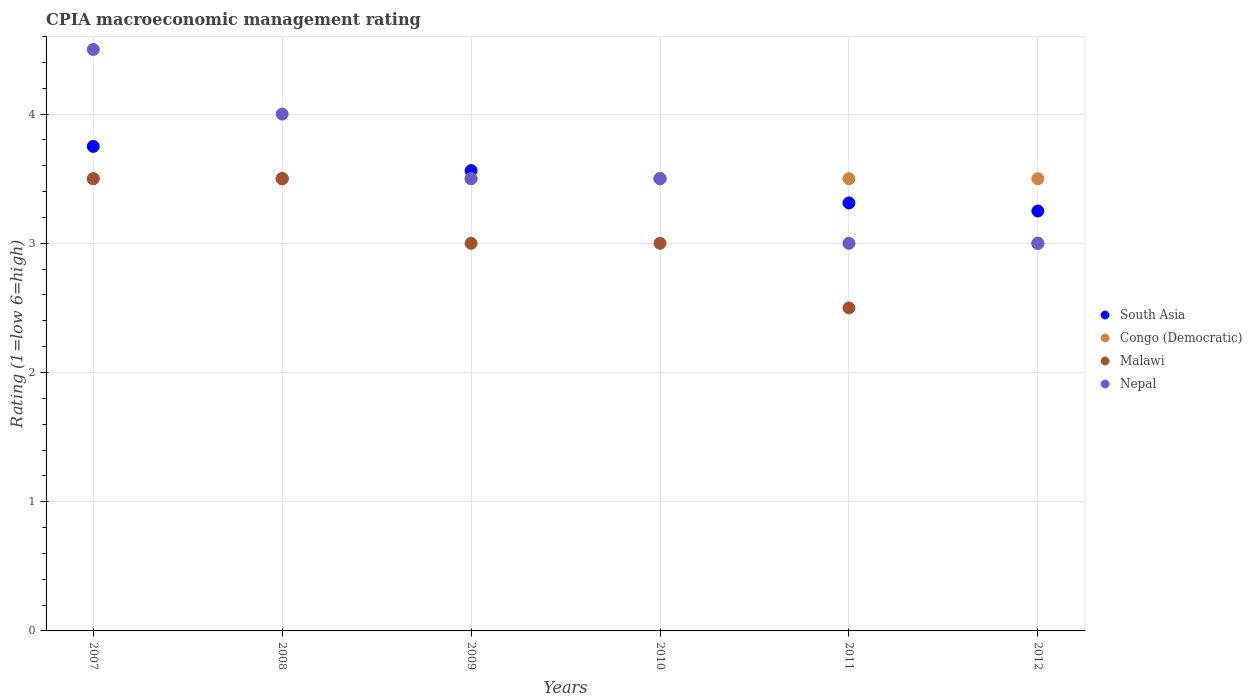How many different coloured dotlines are there?
Provide a succinct answer. 4. What is the CPIA rating in South Asia in 2009?
Your response must be concise. 3.56. Across all years, what is the maximum CPIA rating in South Asia?
Ensure brevity in your answer.  3.75. Across all years, what is the minimum CPIA rating in South Asia?
Make the answer very short. 3.25. In which year was the CPIA rating in Malawi minimum?
Your answer should be very brief. 2011. What is the difference between the CPIA rating in South Asia in 2010 and that in 2012?
Give a very brief answer. 0.25. What is the difference between the CPIA rating in Malawi in 2011 and the CPIA rating in South Asia in 2010?
Keep it short and to the point. -1. What is the ratio of the CPIA rating in South Asia in 2008 to that in 2012?
Offer a very short reply. 1.08. Is the CPIA rating in South Asia in 2010 less than that in 2012?
Provide a short and direct response. No. Is the difference between the CPIA rating in Malawi in 2009 and 2010 greater than the difference between the CPIA rating in South Asia in 2009 and 2010?
Give a very brief answer. No. What is the difference between the highest and the second highest CPIA rating in Nepal?
Offer a very short reply. 0.5. What is the difference between the highest and the lowest CPIA rating in Nepal?
Offer a very short reply. 1.5. Is the sum of the CPIA rating in Congo (Democratic) in 2008 and 2012 greater than the maximum CPIA rating in Nepal across all years?
Your response must be concise. Yes. Is it the case that in every year, the sum of the CPIA rating in Nepal and CPIA rating in South Asia  is greater than the sum of CPIA rating in Congo (Democratic) and CPIA rating in Malawi?
Ensure brevity in your answer.  No. Is it the case that in every year, the sum of the CPIA rating in Malawi and CPIA rating in Nepal  is greater than the CPIA rating in South Asia?
Your answer should be very brief. Yes. Does the CPIA rating in South Asia monotonically increase over the years?
Offer a very short reply. No. Is the CPIA rating in Nepal strictly greater than the CPIA rating in Malawi over the years?
Your answer should be very brief. No. Is the CPIA rating in Congo (Democratic) strictly less than the CPIA rating in Nepal over the years?
Provide a succinct answer. No. What is the difference between two consecutive major ticks on the Y-axis?
Give a very brief answer. 1. How many legend labels are there?
Provide a succinct answer. 4. How are the legend labels stacked?
Your answer should be compact. Vertical. What is the title of the graph?
Offer a very short reply. CPIA macroeconomic management rating. What is the Rating (1=low 6=high) in South Asia in 2007?
Provide a succinct answer. 3.75. What is the Rating (1=low 6=high) in Malawi in 2007?
Ensure brevity in your answer.  3.5. What is the Rating (1=low 6=high) in Congo (Democratic) in 2008?
Your answer should be very brief. 3.5. What is the Rating (1=low 6=high) in Nepal in 2008?
Give a very brief answer. 4. What is the Rating (1=low 6=high) of South Asia in 2009?
Ensure brevity in your answer.  3.56. What is the Rating (1=low 6=high) of Congo (Democratic) in 2009?
Provide a short and direct response. 3.5. What is the Rating (1=low 6=high) in Nepal in 2009?
Make the answer very short. 3.5. What is the Rating (1=low 6=high) in South Asia in 2010?
Your answer should be very brief. 3.5. What is the Rating (1=low 6=high) in Congo (Democratic) in 2010?
Your response must be concise. 3.5. What is the Rating (1=low 6=high) of South Asia in 2011?
Give a very brief answer. 3.31. What is the Rating (1=low 6=high) in Nepal in 2011?
Your answer should be compact. 3. What is the Rating (1=low 6=high) in South Asia in 2012?
Offer a very short reply. 3.25. What is the Rating (1=low 6=high) in Malawi in 2012?
Your answer should be compact. 3. Across all years, what is the maximum Rating (1=low 6=high) of South Asia?
Your answer should be compact. 3.75. Across all years, what is the maximum Rating (1=low 6=high) of Nepal?
Make the answer very short. 4.5. Across all years, what is the minimum Rating (1=low 6=high) of Congo (Democratic)?
Ensure brevity in your answer.  3.5. Across all years, what is the minimum Rating (1=low 6=high) of Nepal?
Provide a short and direct response. 3. What is the total Rating (1=low 6=high) of South Asia in the graph?
Provide a succinct answer. 20.88. What is the total Rating (1=low 6=high) of Congo (Democratic) in the graph?
Offer a terse response. 21. What is the difference between the Rating (1=low 6=high) in Congo (Democratic) in 2007 and that in 2008?
Your answer should be very brief. 0. What is the difference between the Rating (1=low 6=high) in Nepal in 2007 and that in 2008?
Your answer should be very brief. 0.5. What is the difference between the Rating (1=low 6=high) in South Asia in 2007 and that in 2009?
Offer a terse response. 0.19. What is the difference between the Rating (1=low 6=high) of Congo (Democratic) in 2007 and that in 2009?
Keep it short and to the point. 0. What is the difference between the Rating (1=low 6=high) of South Asia in 2007 and that in 2010?
Your response must be concise. 0.25. What is the difference between the Rating (1=low 6=high) of Malawi in 2007 and that in 2010?
Your response must be concise. 0.5. What is the difference between the Rating (1=low 6=high) of Nepal in 2007 and that in 2010?
Provide a succinct answer. 1. What is the difference between the Rating (1=low 6=high) of South Asia in 2007 and that in 2011?
Give a very brief answer. 0.44. What is the difference between the Rating (1=low 6=high) of Malawi in 2007 and that in 2012?
Provide a succinct answer. 0.5. What is the difference between the Rating (1=low 6=high) of Nepal in 2007 and that in 2012?
Provide a short and direct response. 1.5. What is the difference between the Rating (1=low 6=high) in South Asia in 2008 and that in 2009?
Offer a very short reply. -0.06. What is the difference between the Rating (1=low 6=high) in Congo (Democratic) in 2008 and that in 2009?
Make the answer very short. 0. What is the difference between the Rating (1=low 6=high) of Congo (Democratic) in 2008 and that in 2010?
Offer a very short reply. 0. What is the difference between the Rating (1=low 6=high) in South Asia in 2008 and that in 2011?
Ensure brevity in your answer.  0.19. What is the difference between the Rating (1=low 6=high) of Congo (Democratic) in 2008 and that in 2011?
Make the answer very short. 0. What is the difference between the Rating (1=low 6=high) of Malawi in 2008 and that in 2011?
Your response must be concise. 1. What is the difference between the Rating (1=low 6=high) of Congo (Democratic) in 2008 and that in 2012?
Give a very brief answer. 0. What is the difference between the Rating (1=low 6=high) in South Asia in 2009 and that in 2010?
Your answer should be compact. 0.06. What is the difference between the Rating (1=low 6=high) of Congo (Democratic) in 2009 and that in 2010?
Provide a succinct answer. 0. What is the difference between the Rating (1=low 6=high) in Malawi in 2009 and that in 2010?
Your response must be concise. 0. What is the difference between the Rating (1=low 6=high) of Congo (Democratic) in 2009 and that in 2011?
Keep it short and to the point. 0. What is the difference between the Rating (1=low 6=high) of Malawi in 2009 and that in 2011?
Your answer should be compact. 0.5. What is the difference between the Rating (1=low 6=high) of South Asia in 2009 and that in 2012?
Keep it short and to the point. 0.31. What is the difference between the Rating (1=low 6=high) in South Asia in 2010 and that in 2011?
Provide a short and direct response. 0.19. What is the difference between the Rating (1=low 6=high) in Congo (Democratic) in 2010 and that in 2011?
Give a very brief answer. 0. What is the difference between the Rating (1=low 6=high) in Malawi in 2010 and that in 2011?
Offer a terse response. 0.5. What is the difference between the Rating (1=low 6=high) in South Asia in 2010 and that in 2012?
Provide a short and direct response. 0.25. What is the difference between the Rating (1=low 6=high) in Congo (Democratic) in 2010 and that in 2012?
Keep it short and to the point. 0. What is the difference between the Rating (1=low 6=high) of Nepal in 2010 and that in 2012?
Your answer should be compact. 0.5. What is the difference between the Rating (1=low 6=high) of South Asia in 2011 and that in 2012?
Give a very brief answer. 0.06. What is the difference between the Rating (1=low 6=high) of Congo (Democratic) in 2011 and that in 2012?
Your response must be concise. 0. What is the difference between the Rating (1=low 6=high) in Malawi in 2011 and that in 2012?
Keep it short and to the point. -0.5. What is the difference between the Rating (1=low 6=high) of South Asia in 2007 and the Rating (1=low 6=high) of Congo (Democratic) in 2008?
Give a very brief answer. 0.25. What is the difference between the Rating (1=low 6=high) of Congo (Democratic) in 2007 and the Rating (1=low 6=high) of Nepal in 2008?
Your answer should be compact. -0.5. What is the difference between the Rating (1=low 6=high) in South Asia in 2007 and the Rating (1=low 6=high) in Congo (Democratic) in 2009?
Offer a very short reply. 0.25. What is the difference between the Rating (1=low 6=high) in South Asia in 2007 and the Rating (1=low 6=high) in Malawi in 2009?
Offer a terse response. 0.75. What is the difference between the Rating (1=low 6=high) in South Asia in 2007 and the Rating (1=low 6=high) in Nepal in 2009?
Provide a short and direct response. 0.25. What is the difference between the Rating (1=low 6=high) in Congo (Democratic) in 2007 and the Rating (1=low 6=high) in Nepal in 2009?
Offer a terse response. 0. What is the difference between the Rating (1=low 6=high) in South Asia in 2007 and the Rating (1=low 6=high) in Congo (Democratic) in 2010?
Offer a very short reply. 0.25. What is the difference between the Rating (1=low 6=high) in South Asia in 2007 and the Rating (1=low 6=high) in Nepal in 2010?
Provide a succinct answer. 0.25. What is the difference between the Rating (1=low 6=high) in Malawi in 2007 and the Rating (1=low 6=high) in Nepal in 2010?
Your answer should be very brief. 0. What is the difference between the Rating (1=low 6=high) in Congo (Democratic) in 2007 and the Rating (1=low 6=high) in Nepal in 2011?
Provide a short and direct response. 0.5. What is the difference between the Rating (1=low 6=high) of Malawi in 2007 and the Rating (1=low 6=high) of Nepal in 2011?
Offer a terse response. 0.5. What is the difference between the Rating (1=low 6=high) in South Asia in 2007 and the Rating (1=low 6=high) in Nepal in 2012?
Provide a succinct answer. 0.75. What is the difference between the Rating (1=low 6=high) of Congo (Democratic) in 2007 and the Rating (1=low 6=high) of Nepal in 2012?
Keep it short and to the point. 0.5. What is the difference between the Rating (1=low 6=high) in South Asia in 2008 and the Rating (1=low 6=high) in Nepal in 2009?
Your answer should be compact. 0. What is the difference between the Rating (1=low 6=high) in Malawi in 2008 and the Rating (1=low 6=high) in Nepal in 2009?
Your response must be concise. 0. What is the difference between the Rating (1=low 6=high) in South Asia in 2008 and the Rating (1=low 6=high) in Malawi in 2010?
Your answer should be very brief. 0.5. What is the difference between the Rating (1=low 6=high) of South Asia in 2008 and the Rating (1=low 6=high) of Nepal in 2010?
Your response must be concise. 0. What is the difference between the Rating (1=low 6=high) of Congo (Democratic) in 2008 and the Rating (1=low 6=high) of Nepal in 2010?
Ensure brevity in your answer.  0. What is the difference between the Rating (1=low 6=high) in Malawi in 2008 and the Rating (1=low 6=high) in Nepal in 2010?
Offer a very short reply. 0. What is the difference between the Rating (1=low 6=high) of South Asia in 2008 and the Rating (1=low 6=high) of Malawi in 2011?
Your response must be concise. 1. What is the difference between the Rating (1=low 6=high) in South Asia in 2008 and the Rating (1=low 6=high) in Nepal in 2011?
Your answer should be very brief. 0.5. What is the difference between the Rating (1=low 6=high) in Congo (Democratic) in 2008 and the Rating (1=low 6=high) in Malawi in 2011?
Your answer should be compact. 1. What is the difference between the Rating (1=low 6=high) in Congo (Democratic) in 2008 and the Rating (1=low 6=high) in Nepal in 2011?
Keep it short and to the point. 0.5. What is the difference between the Rating (1=low 6=high) in South Asia in 2008 and the Rating (1=low 6=high) in Congo (Democratic) in 2012?
Your answer should be compact. 0. What is the difference between the Rating (1=low 6=high) of South Asia in 2008 and the Rating (1=low 6=high) of Malawi in 2012?
Ensure brevity in your answer.  0.5. What is the difference between the Rating (1=low 6=high) in South Asia in 2008 and the Rating (1=low 6=high) in Nepal in 2012?
Keep it short and to the point. 0.5. What is the difference between the Rating (1=low 6=high) in Congo (Democratic) in 2008 and the Rating (1=low 6=high) in Malawi in 2012?
Offer a terse response. 0.5. What is the difference between the Rating (1=low 6=high) of Congo (Democratic) in 2008 and the Rating (1=low 6=high) of Nepal in 2012?
Ensure brevity in your answer.  0.5. What is the difference between the Rating (1=low 6=high) of South Asia in 2009 and the Rating (1=low 6=high) of Congo (Democratic) in 2010?
Provide a succinct answer. 0.06. What is the difference between the Rating (1=low 6=high) in South Asia in 2009 and the Rating (1=low 6=high) in Malawi in 2010?
Provide a short and direct response. 0.56. What is the difference between the Rating (1=low 6=high) of South Asia in 2009 and the Rating (1=low 6=high) of Nepal in 2010?
Offer a very short reply. 0.06. What is the difference between the Rating (1=low 6=high) in Congo (Democratic) in 2009 and the Rating (1=low 6=high) in Nepal in 2010?
Your answer should be very brief. 0. What is the difference between the Rating (1=low 6=high) of Malawi in 2009 and the Rating (1=low 6=high) of Nepal in 2010?
Your answer should be compact. -0.5. What is the difference between the Rating (1=low 6=high) of South Asia in 2009 and the Rating (1=low 6=high) of Congo (Democratic) in 2011?
Keep it short and to the point. 0.06. What is the difference between the Rating (1=low 6=high) of South Asia in 2009 and the Rating (1=low 6=high) of Malawi in 2011?
Your answer should be very brief. 1.06. What is the difference between the Rating (1=low 6=high) of South Asia in 2009 and the Rating (1=low 6=high) of Nepal in 2011?
Give a very brief answer. 0.56. What is the difference between the Rating (1=low 6=high) in Malawi in 2009 and the Rating (1=low 6=high) in Nepal in 2011?
Provide a succinct answer. 0. What is the difference between the Rating (1=low 6=high) in South Asia in 2009 and the Rating (1=low 6=high) in Congo (Democratic) in 2012?
Offer a terse response. 0.06. What is the difference between the Rating (1=low 6=high) in South Asia in 2009 and the Rating (1=low 6=high) in Malawi in 2012?
Your response must be concise. 0.56. What is the difference between the Rating (1=low 6=high) of South Asia in 2009 and the Rating (1=low 6=high) of Nepal in 2012?
Provide a short and direct response. 0.56. What is the difference between the Rating (1=low 6=high) in Congo (Democratic) in 2009 and the Rating (1=low 6=high) in Malawi in 2012?
Your response must be concise. 0.5. What is the difference between the Rating (1=low 6=high) of South Asia in 2010 and the Rating (1=low 6=high) of Congo (Democratic) in 2011?
Make the answer very short. 0. What is the difference between the Rating (1=low 6=high) in South Asia in 2010 and the Rating (1=low 6=high) in Nepal in 2011?
Provide a short and direct response. 0.5. What is the difference between the Rating (1=low 6=high) in Congo (Democratic) in 2010 and the Rating (1=low 6=high) in Nepal in 2011?
Offer a very short reply. 0.5. What is the difference between the Rating (1=low 6=high) of Malawi in 2010 and the Rating (1=low 6=high) of Nepal in 2011?
Keep it short and to the point. 0. What is the difference between the Rating (1=low 6=high) in South Asia in 2010 and the Rating (1=low 6=high) in Congo (Democratic) in 2012?
Offer a terse response. 0. What is the difference between the Rating (1=low 6=high) of South Asia in 2010 and the Rating (1=low 6=high) of Malawi in 2012?
Provide a short and direct response. 0.5. What is the difference between the Rating (1=low 6=high) in Congo (Democratic) in 2010 and the Rating (1=low 6=high) in Nepal in 2012?
Your response must be concise. 0.5. What is the difference between the Rating (1=low 6=high) of Malawi in 2010 and the Rating (1=low 6=high) of Nepal in 2012?
Your answer should be compact. 0. What is the difference between the Rating (1=low 6=high) of South Asia in 2011 and the Rating (1=low 6=high) of Congo (Democratic) in 2012?
Your response must be concise. -0.19. What is the difference between the Rating (1=low 6=high) in South Asia in 2011 and the Rating (1=low 6=high) in Malawi in 2012?
Ensure brevity in your answer.  0.31. What is the difference between the Rating (1=low 6=high) of South Asia in 2011 and the Rating (1=low 6=high) of Nepal in 2012?
Give a very brief answer. 0.31. What is the difference between the Rating (1=low 6=high) of Congo (Democratic) in 2011 and the Rating (1=low 6=high) of Nepal in 2012?
Your answer should be very brief. 0.5. What is the average Rating (1=low 6=high) of South Asia per year?
Your response must be concise. 3.48. What is the average Rating (1=low 6=high) in Malawi per year?
Provide a succinct answer. 3.08. What is the average Rating (1=low 6=high) in Nepal per year?
Give a very brief answer. 3.58. In the year 2007, what is the difference between the Rating (1=low 6=high) in South Asia and Rating (1=low 6=high) in Congo (Democratic)?
Keep it short and to the point. 0.25. In the year 2007, what is the difference between the Rating (1=low 6=high) of South Asia and Rating (1=low 6=high) of Malawi?
Provide a succinct answer. 0.25. In the year 2007, what is the difference between the Rating (1=low 6=high) of South Asia and Rating (1=low 6=high) of Nepal?
Provide a short and direct response. -0.75. In the year 2007, what is the difference between the Rating (1=low 6=high) of Congo (Democratic) and Rating (1=low 6=high) of Malawi?
Provide a succinct answer. 0. In the year 2007, what is the difference between the Rating (1=low 6=high) in Malawi and Rating (1=low 6=high) in Nepal?
Make the answer very short. -1. In the year 2008, what is the difference between the Rating (1=low 6=high) of South Asia and Rating (1=low 6=high) of Malawi?
Ensure brevity in your answer.  0. In the year 2008, what is the difference between the Rating (1=low 6=high) in South Asia and Rating (1=low 6=high) in Nepal?
Ensure brevity in your answer.  -0.5. In the year 2008, what is the difference between the Rating (1=low 6=high) of Congo (Democratic) and Rating (1=low 6=high) of Malawi?
Keep it short and to the point. 0. In the year 2009, what is the difference between the Rating (1=low 6=high) in South Asia and Rating (1=low 6=high) in Congo (Democratic)?
Give a very brief answer. 0.06. In the year 2009, what is the difference between the Rating (1=low 6=high) in South Asia and Rating (1=low 6=high) in Malawi?
Your response must be concise. 0.56. In the year 2009, what is the difference between the Rating (1=low 6=high) in South Asia and Rating (1=low 6=high) in Nepal?
Offer a very short reply. 0.06. In the year 2009, what is the difference between the Rating (1=low 6=high) in Congo (Democratic) and Rating (1=low 6=high) in Malawi?
Keep it short and to the point. 0.5. In the year 2009, what is the difference between the Rating (1=low 6=high) of Congo (Democratic) and Rating (1=low 6=high) of Nepal?
Provide a succinct answer. 0. In the year 2009, what is the difference between the Rating (1=low 6=high) in Malawi and Rating (1=low 6=high) in Nepal?
Keep it short and to the point. -0.5. In the year 2010, what is the difference between the Rating (1=low 6=high) in South Asia and Rating (1=low 6=high) in Congo (Democratic)?
Your response must be concise. 0. In the year 2011, what is the difference between the Rating (1=low 6=high) of South Asia and Rating (1=low 6=high) of Congo (Democratic)?
Give a very brief answer. -0.19. In the year 2011, what is the difference between the Rating (1=low 6=high) in South Asia and Rating (1=low 6=high) in Malawi?
Make the answer very short. 0.81. In the year 2011, what is the difference between the Rating (1=low 6=high) of South Asia and Rating (1=low 6=high) of Nepal?
Your answer should be compact. 0.31. In the year 2011, what is the difference between the Rating (1=low 6=high) in Congo (Democratic) and Rating (1=low 6=high) in Nepal?
Your response must be concise. 0.5. In the year 2011, what is the difference between the Rating (1=low 6=high) of Malawi and Rating (1=low 6=high) of Nepal?
Provide a short and direct response. -0.5. In the year 2012, what is the difference between the Rating (1=low 6=high) of South Asia and Rating (1=low 6=high) of Malawi?
Offer a very short reply. 0.25. In the year 2012, what is the difference between the Rating (1=low 6=high) of Malawi and Rating (1=low 6=high) of Nepal?
Make the answer very short. 0. What is the ratio of the Rating (1=low 6=high) of South Asia in 2007 to that in 2008?
Ensure brevity in your answer.  1.07. What is the ratio of the Rating (1=low 6=high) in Congo (Democratic) in 2007 to that in 2008?
Give a very brief answer. 1. What is the ratio of the Rating (1=low 6=high) of Nepal in 2007 to that in 2008?
Your response must be concise. 1.12. What is the ratio of the Rating (1=low 6=high) of South Asia in 2007 to that in 2009?
Offer a terse response. 1.05. What is the ratio of the Rating (1=low 6=high) of South Asia in 2007 to that in 2010?
Make the answer very short. 1.07. What is the ratio of the Rating (1=low 6=high) of Nepal in 2007 to that in 2010?
Ensure brevity in your answer.  1.29. What is the ratio of the Rating (1=low 6=high) of South Asia in 2007 to that in 2011?
Provide a short and direct response. 1.13. What is the ratio of the Rating (1=low 6=high) in Congo (Democratic) in 2007 to that in 2011?
Offer a terse response. 1. What is the ratio of the Rating (1=low 6=high) in South Asia in 2007 to that in 2012?
Give a very brief answer. 1.15. What is the ratio of the Rating (1=low 6=high) of South Asia in 2008 to that in 2009?
Your answer should be very brief. 0.98. What is the ratio of the Rating (1=low 6=high) in Malawi in 2008 to that in 2009?
Your response must be concise. 1.17. What is the ratio of the Rating (1=low 6=high) in South Asia in 2008 to that in 2010?
Provide a succinct answer. 1. What is the ratio of the Rating (1=low 6=high) in Congo (Democratic) in 2008 to that in 2010?
Your response must be concise. 1. What is the ratio of the Rating (1=low 6=high) of Nepal in 2008 to that in 2010?
Ensure brevity in your answer.  1.14. What is the ratio of the Rating (1=low 6=high) of South Asia in 2008 to that in 2011?
Offer a terse response. 1.06. What is the ratio of the Rating (1=low 6=high) of Malawi in 2008 to that in 2011?
Keep it short and to the point. 1.4. What is the ratio of the Rating (1=low 6=high) in Nepal in 2008 to that in 2011?
Offer a terse response. 1.33. What is the ratio of the Rating (1=low 6=high) of South Asia in 2008 to that in 2012?
Your answer should be compact. 1.08. What is the ratio of the Rating (1=low 6=high) in Congo (Democratic) in 2008 to that in 2012?
Make the answer very short. 1. What is the ratio of the Rating (1=low 6=high) in Nepal in 2008 to that in 2012?
Provide a succinct answer. 1.33. What is the ratio of the Rating (1=low 6=high) in South Asia in 2009 to that in 2010?
Your answer should be compact. 1.02. What is the ratio of the Rating (1=low 6=high) in Congo (Democratic) in 2009 to that in 2010?
Your response must be concise. 1. What is the ratio of the Rating (1=low 6=high) of Malawi in 2009 to that in 2010?
Provide a short and direct response. 1. What is the ratio of the Rating (1=low 6=high) of South Asia in 2009 to that in 2011?
Give a very brief answer. 1.08. What is the ratio of the Rating (1=low 6=high) in South Asia in 2009 to that in 2012?
Your response must be concise. 1.1. What is the ratio of the Rating (1=low 6=high) of Congo (Democratic) in 2009 to that in 2012?
Provide a short and direct response. 1. What is the ratio of the Rating (1=low 6=high) of Malawi in 2009 to that in 2012?
Give a very brief answer. 1. What is the ratio of the Rating (1=low 6=high) of Nepal in 2009 to that in 2012?
Provide a short and direct response. 1.17. What is the ratio of the Rating (1=low 6=high) of South Asia in 2010 to that in 2011?
Your answer should be compact. 1.06. What is the ratio of the Rating (1=low 6=high) of Congo (Democratic) in 2010 to that in 2011?
Offer a very short reply. 1. What is the ratio of the Rating (1=low 6=high) in Malawi in 2010 to that in 2011?
Offer a terse response. 1.2. What is the ratio of the Rating (1=low 6=high) of South Asia in 2010 to that in 2012?
Your answer should be very brief. 1.08. What is the ratio of the Rating (1=low 6=high) in South Asia in 2011 to that in 2012?
Your answer should be very brief. 1.02. What is the difference between the highest and the second highest Rating (1=low 6=high) of South Asia?
Provide a succinct answer. 0.19. What is the difference between the highest and the lowest Rating (1=low 6=high) of Malawi?
Offer a very short reply. 1. 